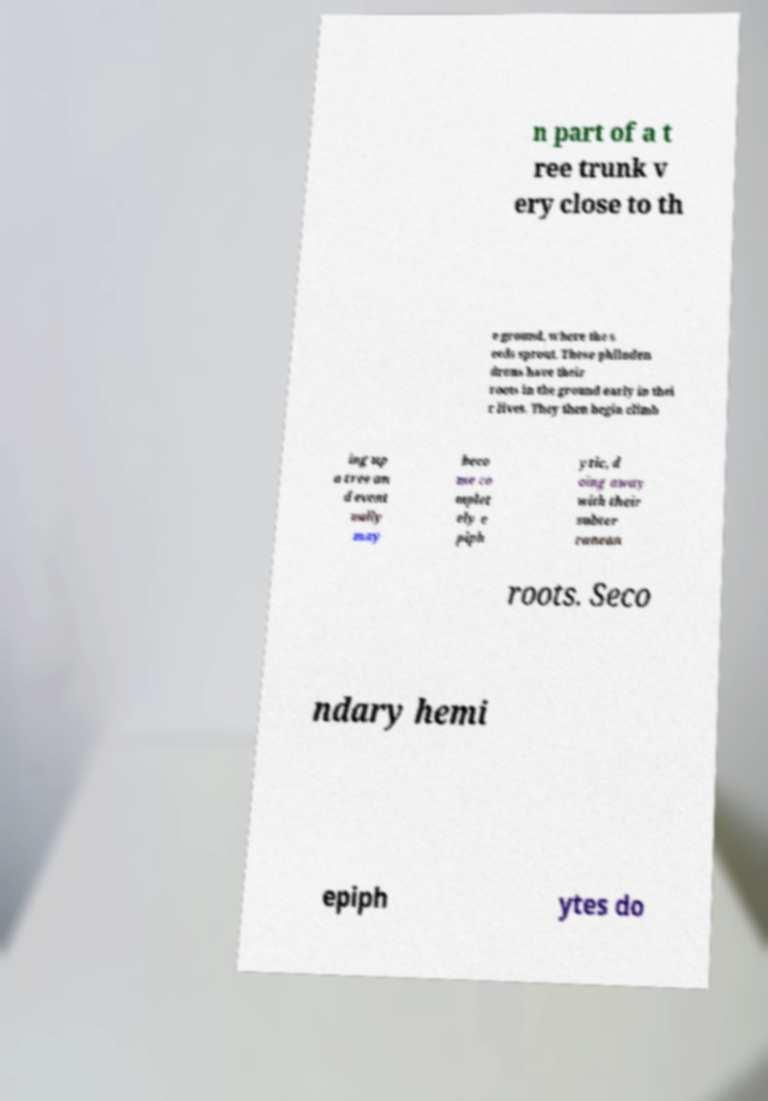Can you accurately transcribe the text from the provided image for me? n part of a t ree trunk v ery close to th e ground, where the s eeds sprout. These philoden drons have their roots in the ground early in thei r lives. They then begin climb ing up a tree an d event ually may beco me co mplet ely e piph ytic, d oing away with their subter ranean roots. Seco ndary hemi epiph ytes do 